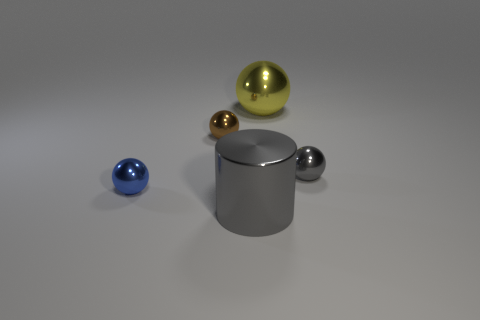Add 3 big brown matte cubes. How many objects exist? 8 Subtract all spheres. How many objects are left? 1 Add 1 big things. How many big things are left? 3 Add 3 large blue matte balls. How many large blue matte balls exist? 3 Subtract 1 blue balls. How many objects are left? 4 Subtract all big green shiny cylinders. Subtract all small blue spheres. How many objects are left? 4 